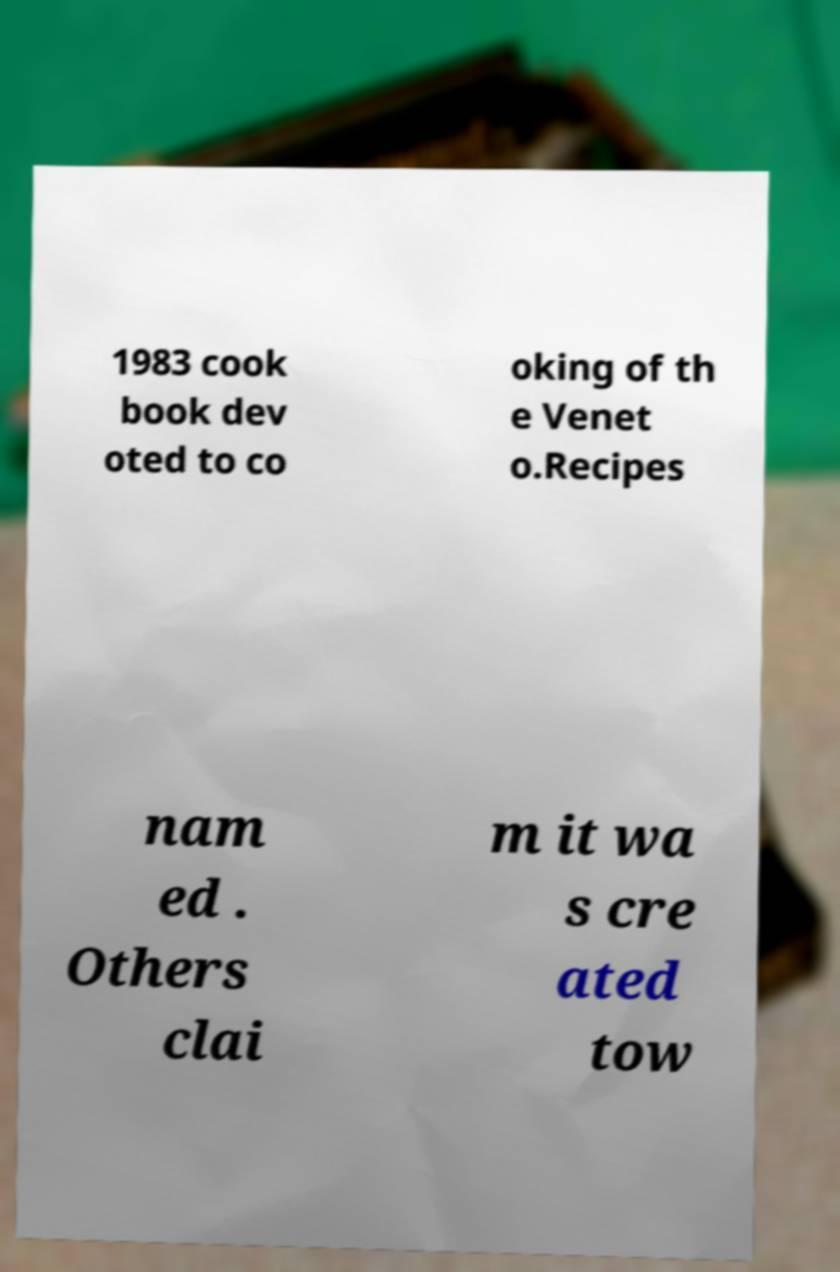Please identify and transcribe the text found in this image. 1983 cook book dev oted to co oking of th e Venet o.Recipes nam ed . Others clai m it wa s cre ated tow 